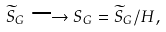Convert formula to latex. <formula><loc_0><loc_0><loc_500><loc_500>\widetilde { S } _ { G } \longrightarrow S _ { G } = \widetilde { S } _ { G } / H ,</formula> 